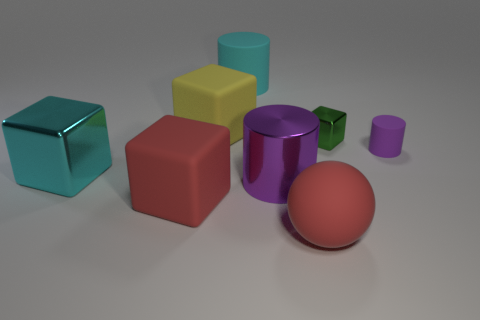Subtract all big cubes. How many cubes are left? 1 Add 2 small cylinders. How many objects exist? 10 Subtract 3 blocks. How many blocks are left? 1 Subtract all purple cylinders. How many cylinders are left? 1 Subtract all green cubes. How many cyan cylinders are left? 1 Subtract all red cylinders. Subtract all red spheres. How many cylinders are left? 3 Subtract all large metallic cubes. Subtract all small purple metallic balls. How many objects are left? 7 Add 4 cylinders. How many cylinders are left? 7 Add 5 gray cylinders. How many gray cylinders exist? 5 Subtract 1 red spheres. How many objects are left? 7 